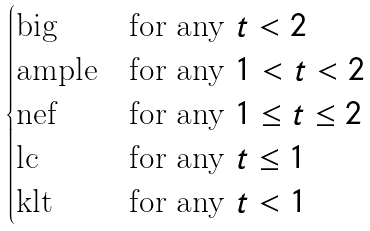Convert formula to latex. <formula><loc_0><loc_0><loc_500><loc_500>\begin{cases} \text {big} & \text {for any $t<2$} \\ \text {ample} & \text {for any $1<t<2$} \\ \text {nef} & \text {for any $1\leq t\leq 2$} \\ \text {lc} & \text {for any $t\leq 1$} \\ \text {klt} & \text {for any $t<1$} \\ \end{cases}</formula> 